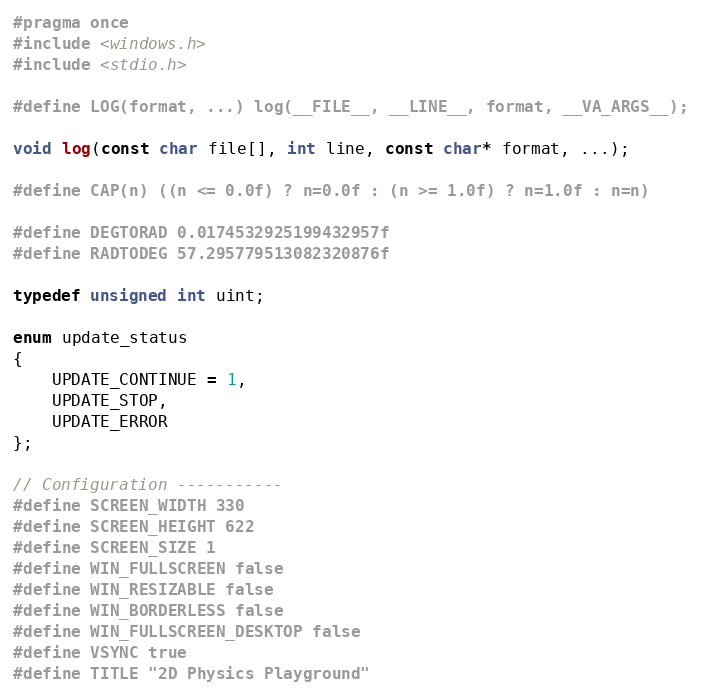<code> <loc_0><loc_0><loc_500><loc_500><_C_>#pragma once
#include <windows.h>
#include <stdio.h>

#define LOG(format, ...) log(__FILE__, __LINE__, format, __VA_ARGS__);

void log(const char file[], int line, const char* format, ...);

#define CAP(n) ((n <= 0.0f) ? n=0.0f : (n >= 1.0f) ? n=1.0f : n=n)

#define DEGTORAD 0.0174532925199432957f
#define RADTODEG 57.295779513082320876f

typedef unsigned int uint;

enum update_status
{
	UPDATE_CONTINUE = 1,
	UPDATE_STOP,
	UPDATE_ERROR
};

// Configuration -----------
#define SCREEN_WIDTH 330
#define SCREEN_HEIGHT 622
#define SCREEN_SIZE 1
#define WIN_FULLSCREEN false
#define WIN_RESIZABLE false
#define WIN_BORDERLESS false
#define WIN_FULLSCREEN_DESKTOP false
#define VSYNC true
#define TITLE "2D Physics Playground"</code> 